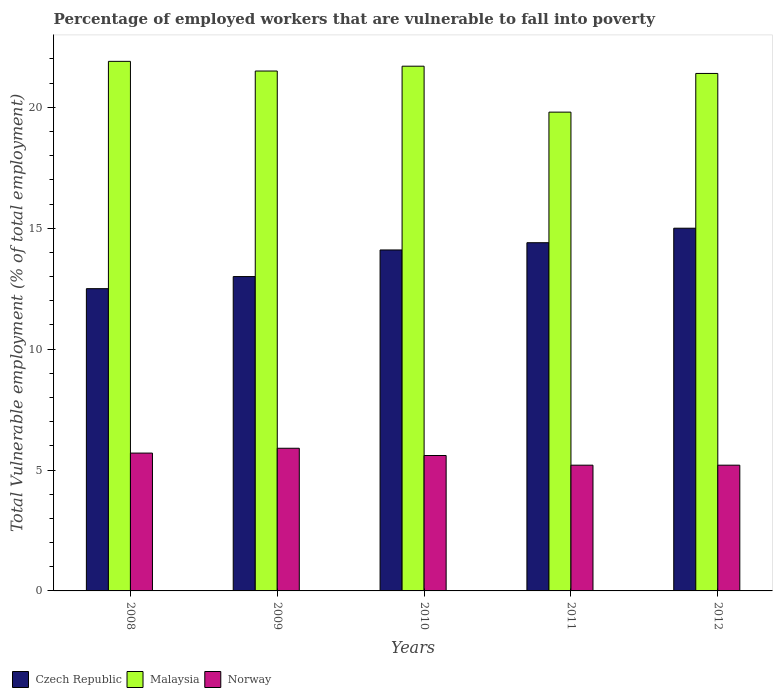Are the number of bars on each tick of the X-axis equal?
Provide a succinct answer. Yes. What is the label of the 2nd group of bars from the left?
Make the answer very short. 2009. What is the percentage of employed workers who are vulnerable to fall into poverty in Norway in 2010?
Offer a terse response. 5.6. Across all years, what is the maximum percentage of employed workers who are vulnerable to fall into poverty in Norway?
Make the answer very short. 5.9. Across all years, what is the minimum percentage of employed workers who are vulnerable to fall into poverty in Czech Republic?
Give a very brief answer. 12.5. In which year was the percentage of employed workers who are vulnerable to fall into poverty in Norway minimum?
Ensure brevity in your answer.  2011. What is the total percentage of employed workers who are vulnerable to fall into poverty in Czech Republic in the graph?
Offer a very short reply. 69. What is the difference between the percentage of employed workers who are vulnerable to fall into poverty in Malaysia in 2008 and that in 2010?
Make the answer very short. 0.2. What is the difference between the percentage of employed workers who are vulnerable to fall into poverty in Malaysia in 2010 and the percentage of employed workers who are vulnerable to fall into poverty in Norway in 2009?
Your answer should be compact. 15.8. In the year 2009, what is the difference between the percentage of employed workers who are vulnerable to fall into poverty in Malaysia and percentage of employed workers who are vulnerable to fall into poverty in Czech Republic?
Offer a terse response. 8.5. In how many years, is the percentage of employed workers who are vulnerable to fall into poverty in Czech Republic greater than 8 %?
Offer a terse response. 5. What is the ratio of the percentage of employed workers who are vulnerable to fall into poverty in Malaysia in 2010 to that in 2012?
Offer a terse response. 1.01. Is the percentage of employed workers who are vulnerable to fall into poverty in Malaysia in 2009 less than that in 2010?
Provide a succinct answer. Yes. What is the difference between the highest and the second highest percentage of employed workers who are vulnerable to fall into poverty in Norway?
Provide a succinct answer. 0.2. What is the difference between the highest and the lowest percentage of employed workers who are vulnerable to fall into poverty in Czech Republic?
Offer a very short reply. 2.5. In how many years, is the percentage of employed workers who are vulnerable to fall into poverty in Czech Republic greater than the average percentage of employed workers who are vulnerable to fall into poverty in Czech Republic taken over all years?
Provide a short and direct response. 3. Is the sum of the percentage of employed workers who are vulnerable to fall into poverty in Czech Republic in 2009 and 2011 greater than the maximum percentage of employed workers who are vulnerable to fall into poverty in Malaysia across all years?
Give a very brief answer. Yes. What does the 3rd bar from the left in 2010 represents?
Your answer should be very brief. Norway. What does the 1st bar from the right in 2009 represents?
Your answer should be very brief. Norway. Is it the case that in every year, the sum of the percentage of employed workers who are vulnerable to fall into poverty in Czech Republic and percentage of employed workers who are vulnerable to fall into poverty in Norway is greater than the percentage of employed workers who are vulnerable to fall into poverty in Malaysia?
Give a very brief answer. No. How many bars are there?
Your answer should be very brief. 15. How many years are there in the graph?
Your response must be concise. 5. What is the difference between two consecutive major ticks on the Y-axis?
Provide a succinct answer. 5. Are the values on the major ticks of Y-axis written in scientific E-notation?
Your answer should be compact. No. Does the graph contain any zero values?
Offer a terse response. No. How many legend labels are there?
Offer a terse response. 3. What is the title of the graph?
Offer a very short reply. Percentage of employed workers that are vulnerable to fall into poverty. Does "Benin" appear as one of the legend labels in the graph?
Ensure brevity in your answer.  No. What is the label or title of the Y-axis?
Ensure brevity in your answer.  Total Vulnerable employment (% of total employment). What is the Total Vulnerable employment (% of total employment) of Czech Republic in 2008?
Provide a succinct answer. 12.5. What is the Total Vulnerable employment (% of total employment) in Malaysia in 2008?
Your response must be concise. 21.9. What is the Total Vulnerable employment (% of total employment) in Norway in 2008?
Keep it short and to the point. 5.7. What is the Total Vulnerable employment (% of total employment) of Malaysia in 2009?
Offer a terse response. 21.5. What is the Total Vulnerable employment (% of total employment) in Norway in 2009?
Offer a very short reply. 5.9. What is the Total Vulnerable employment (% of total employment) of Czech Republic in 2010?
Offer a very short reply. 14.1. What is the Total Vulnerable employment (% of total employment) of Malaysia in 2010?
Give a very brief answer. 21.7. What is the Total Vulnerable employment (% of total employment) in Norway in 2010?
Keep it short and to the point. 5.6. What is the Total Vulnerable employment (% of total employment) in Czech Republic in 2011?
Make the answer very short. 14.4. What is the Total Vulnerable employment (% of total employment) in Malaysia in 2011?
Provide a succinct answer. 19.8. What is the Total Vulnerable employment (% of total employment) of Norway in 2011?
Offer a very short reply. 5.2. What is the Total Vulnerable employment (% of total employment) in Czech Republic in 2012?
Give a very brief answer. 15. What is the Total Vulnerable employment (% of total employment) in Malaysia in 2012?
Provide a short and direct response. 21.4. What is the Total Vulnerable employment (% of total employment) of Norway in 2012?
Your answer should be compact. 5.2. Across all years, what is the maximum Total Vulnerable employment (% of total employment) in Malaysia?
Ensure brevity in your answer.  21.9. Across all years, what is the maximum Total Vulnerable employment (% of total employment) of Norway?
Make the answer very short. 5.9. Across all years, what is the minimum Total Vulnerable employment (% of total employment) in Malaysia?
Offer a very short reply. 19.8. Across all years, what is the minimum Total Vulnerable employment (% of total employment) of Norway?
Offer a terse response. 5.2. What is the total Total Vulnerable employment (% of total employment) in Malaysia in the graph?
Your answer should be very brief. 106.3. What is the total Total Vulnerable employment (% of total employment) of Norway in the graph?
Offer a very short reply. 27.6. What is the difference between the Total Vulnerable employment (% of total employment) of Czech Republic in 2008 and that in 2010?
Your answer should be very brief. -1.6. What is the difference between the Total Vulnerable employment (% of total employment) of Norway in 2008 and that in 2010?
Ensure brevity in your answer.  0.1. What is the difference between the Total Vulnerable employment (% of total employment) in Norway in 2008 and that in 2011?
Your answer should be compact. 0.5. What is the difference between the Total Vulnerable employment (% of total employment) of Malaysia in 2008 and that in 2012?
Your response must be concise. 0.5. What is the difference between the Total Vulnerable employment (% of total employment) in Norway in 2008 and that in 2012?
Offer a terse response. 0.5. What is the difference between the Total Vulnerable employment (% of total employment) in Malaysia in 2009 and that in 2011?
Your answer should be very brief. 1.7. What is the difference between the Total Vulnerable employment (% of total employment) in Norway in 2009 and that in 2011?
Make the answer very short. 0.7. What is the difference between the Total Vulnerable employment (% of total employment) in Czech Republic in 2010 and that in 2011?
Your answer should be very brief. -0.3. What is the difference between the Total Vulnerable employment (% of total employment) of Czech Republic in 2010 and that in 2012?
Offer a terse response. -0.9. What is the difference between the Total Vulnerable employment (% of total employment) in Malaysia in 2010 and that in 2012?
Provide a short and direct response. 0.3. What is the difference between the Total Vulnerable employment (% of total employment) of Czech Republic in 2011 and that in 2012?
Ensure brevity in your answer.  -0.6. What is the difference between the Total Vulnerable employment (% of total employment) in Czech Republic in 2008 and the Total Vulnerable employment (% of total employment) in Norway in 2009?
Offer a terse response. 6.6. What is the difference between the Total Vulnerable employment (% of total employment) of Malaysia in 2008 and the Total Vulnerable employment (% of total employment) of Norway in 2009?
Offer a terse response. 16. What is the difference between the Total Vulnerable employment (% of total employment) in Czech Republic in 2008 and the Total Vulnerable employment (% of total employment) in Norway in 2010?
Provide a short and direct response. 6.9. What is the difference between the Total Vulnerable employment (% of total employment) in Czech Republic in 2008 and the Total Vulnerable employment (% of total employment) in Malaysia in 2011?
Give a very brief answer. -7.3. What is the difference between the Total Vulnerable employment (% of total employment) of Malaysia in 2008 and the Total Vulnerable employment (% of total employment) of Norway in 2011?
Your response must be concise. 16.7. What is the difference between the Total Vulnerable employment (% of total employment) of Czech Republic in 2008 and the Total Vulnerable employment (% of total employment) of Norway in 2012?
Ensure brevity in your answer.  7.3. What is the difference between the Total Vulnerable employment (% of total employment) of Czech Republic in 2009 and the Total Vulnerable employment (% of total employment) of Malaysia in 2010?
Your answer should be very brief. -8.7. What is the difference between the Total Vulnerable employment (% of total employment) in Czech Republic in 2009 and the Total Vulnerable employment (% of total employment) in Norway in 2011?
Offer a terse response. 7.8. What is the difference between the Total Vulnerable employment (% of total employment) in Malaysia in 2009 and the Total Vulnerable employment (% of total employment) in Norway in 2011?
Provide a short and direct response. 16.3. What is the difference between the Total Vulnerable employment (% of total employment) of Czech Republic in 2009 and the Total Vulnerable employment (% of total employment) of Malaysia in 2012?
Ensure brevity in your answer.  -8.4. What is the difference between the Total Vulnerable employment (% of total employment) in Czech Republic in 2009 and the Total Vulnerable employment (% of total employment) in Norway in 2012?
Ensure brevity in your answer.  7.8. What is the difference between the Total Vulnerable employment (% of total employment) in Malaysia in 2010 and the Total Vulnerable employment (% of total employment) in Norway in 2011?
Keep it short and to the point. 16.5. What is the difference between the Total Vulnerable employment (% of total employment) in Czech Republic in 2010 and the Total Vulnerable employment (% of total employment) in Malaysia in 2012?
Give a very brief answer. -7.3. What is the difference between the Total Vulnerable employment (% of total employment) of Czech Republic in 2011 and the Total Vulnerable employment (% of total employment) of Malaysia in 2012?
Offer a terse response. -7. What is the average Total Vulnerable employment (% of total employment) of Czech Republic per year?
Offer a terse response. 13.8. What is the average Total Vulnerable employment (% of total employment) in Malaysia per year?
Offer a terse response. 21.26. What is the average Total Vulnerable employment (% of total employment) of Norway per year?
Your answer should be compact. 5.52. In the year 2008, what is the difference between the Total Vulnerable employment (% of total employment) in Czech Republic and Total Vulnerable employment (% of total employment) in Malaysia?
Keep it short and to the point. -9.4. In the year 2008, what is the difference between the Total Vulnerable employment (% of total employment) in Czech Republic and Total Vulnerable employment (% of total employment) in Norway?
Offer a very short reply. 6.8. In the year 2009, what is the difference between the Total Vulnerable employment (% of total employment) in Czech Republic and Total Vulnerable employment (% of total employment) in Malaysia?
Offer a very short reply. -8.5. In the year 2009, what is the difference between the Total Vulnerable employment (% of total employment) of Czech Republic and Total Vulnerable employment (% of total employment) of Norway?
Keep it short and to the point. 7.1. In the year 2009, what is the difference between the Total Vulnerable employment (% of total employment) of Malaysia and Total Vulnerable employment (% of total employment) of Norway?
Give a very brief answer. 15.6. In the year 2010, what is the difference between the Total Vulnerable employment (% of total employment) in Czech Republic and Total Vulnerable employment (% of total employment) in Malaysia?
Offer a terse response. -7.6. In the year 2010, what is the difference between the Total Vulnerable employment (% of total employment) in Czech Republic and Total Vulnerable employment (% of total employment) in Norway?
Your answer should be compact. 8.5. In the year 2010, what is the difference between the Total Vulnerable employment (% of total employment) in Malaysia and Total Vulnerable employment (% of total employment) in Norway?
Provide a short and direct response. 16.1. In the year 2011, what is the difference between the Total Vulnerable employment (% of total employment) of Czech Republic and Total Vulnerable employment (% of total employment) of Malaysia?
Keep it short and to the point. -5.4. In the year 2011, what is the difference between the Total Vulnerable employment (% of total employment) in Czech Republic and Total Vulnerable employment (% of total employment) in Norway?
Provide a short and direct response. 9.2. In the year 2012, what is the difference between the Total Vulnerable employment (% of total employment) of Czech Republic and Total Vulnerable employment (% of total employment) of Malaysia?
Ensure brevity in your answer.  -6.4. What is the ratio of the Total Vulnerable employment (% of total employment) in Czech Republic in 2008 to that in 2009?
Keep it short and to the point. 0.96. What is the ratio of the Total Vulnerable employment (% of total employment) in Malaysia in 2008 to that in 2009?
Ensure brevity in your answer.  1.02. What is the ratio of the Total Vulnerable employment (% of total employment) in Norway in 2008 to that in 2009?
Offer a very short reply. 0.97. What is the ratio of the Total Vulnerable employment (% of total employment) in Czech Republic in 2008 to that in 2010?
Your answer should be compact. 0.89. What is the ratio of the Total Vulnerable employment (% of total employment) in Malaysia in 2008 to that in 2010?
Offer a terse response. 1.01. What is the ratio of the Total Vulnerable employment (% of total employment) of Norway in 2008 to that in 2010?
Your answer should be very brief. 1.02. What is the ratio of the Total Vulnerable employment (% of total employment) in Czech Republic in 2008 to that in 2011?
Provide a succinct answer. 0.87. What is the ratio of the Total Vulnerable employment (% of total employment) of Malaysia in 2008 to that in 2011?
Provide a succinct answer. 1.11. What is the ratio of the Total Vulnerable employment (% of total employment) in Norway in 2008 to that in 2011?
Offer a terse response. 1.1. What is the ratio of the Total Vulnerable employment (% of total employment) in Czech Republic in 2008 to that in 2012?
Your response must be concise. 0.83. What is the ratio of the Total Vulnerable employment (% of total employment) of Malaysia in 2008 to that in 2012?
Ensure brevity in your answer.  1.02. What is the ratio of the Total Vulnerable employment (% of total employment) of Norway in 2008 to that in 2012?
Give a very brief answer. 1.1. What is the ratio of the Total Vulnerable employment (% of total employment) in Czech Republic in 2009 to that in 2010?
Your response must be concise. 0.92. What is the ratio of the Total Vulnerable employment (% of total employment) of Norway in 2009 to that in 2010?
Offer a very short reply. 1.05. What is the ratio of the Total Vulnerable employment (% of total employment) of Czech Republic in 2009 to that in 2011?
Your response must be concise. 0.9. What is the ratio of the Total Vulnerable employment (% of total employment) in Malaysia in 2009 to that in 2011?
Offer a terse response. 1.09. What is the ratio of the Total Vulnerable employment (% of total employment) of Norway in 2009 to that in 2011?
Make the answer very short. 1.13. What is the ratio of the Total Vulnerable employment (% of total employment) in Czech Republic in 2009 to that in 2012?
Offer a very short reply. 0.87. What is the ratio of the Total Vulnerable employment (% of total employment) in Malaysia in 2009 to that in 2012?
Your response must be concise. 1. What is the ratio of the Total Vulnerable employment (% of total employment) of Norway in 2009 to that in 2012?
Provide a succinct answer. 1.13. What is the ratio of the Total Vulnerable employment (% of total employment) of Czech Republic in 2010 to that in 2011?
Give a very brief answer. 0.98. What is the ratio of the Total Vulnerable employment (% of total employment) in Malaysia in 2010 to that in 2011?
Your response must be concise. 1.1. What is the ratio of the Total Vulnerable employment (% of total employment) of Czech Republic in 2010 to that in 2012?
Your answer should be compact. 0.94. What is the ratio of the Total Vulnerable employment (% of total employment) of Malaysia in 2010 to that in 2012?
Your answer should be very brief. 1.01. What is the ratio of the Total Vulnerable employment (% of total employment) of Malaysia in 2011 to that in 2012?
Give a very brief answer. 0.93. What is the ratio of the Total Vulnerable employment (% of total employment) in Norway in 2011 to that in 2012?
Offer a very short reply. 1. What is the difference between the highest and the second highest Total Vulnerable employment (% of total employment) in Czech Republic?
Your answer should be compact. 0.6. What is the difference between the highest and the second highest Total Vulnerable employment (% of total employment) in Malaysia?
Provide a succinct answer. 0.2. What is the difference between the highest and the second highest Total Vulnerable employment (% of total employment) of Norway?
Your answer should be compact. 0.2. What is the difference between the highest and the lowest Total Vulnerable employment (% of total employment) of Czech Republic?
Provide a succinct answer. 2.5. What is the difference between the highest and the lowest Total Vulnerable employment (% of total employment) of Norway?
Offer a very short reply. 0.7. 